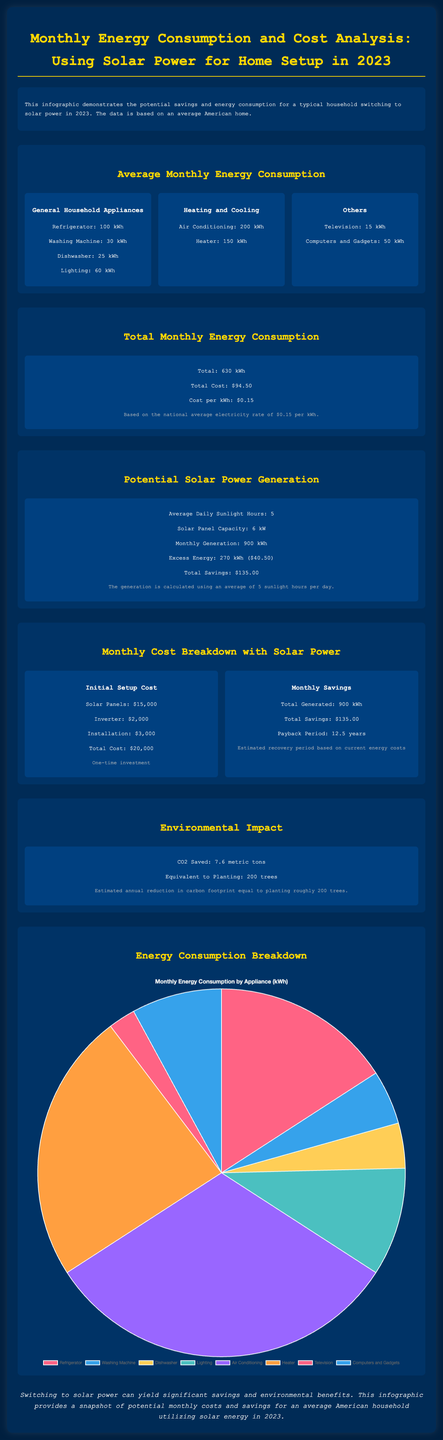What is the total monthly energy consumption? The total monthly energy consumption is listed in the section titled Total Monthly Energy Consumption as 630 kWh.
Answer: 630 kWh What is the cost per kWh? The cost per kWh is outlined in the Total Monthly Energy Consumption section as $0.15.
Answer: $0.15 How much CO2 is saved annually? The environmental impact section specifies that 7.6 metric tons of CO2 are saved annually.
Answer: 7.6 metric tons What is the total cost for solar panel installation? The initial setup cost section indicates the total cost for solar panel installation as $20,000.
Answer: $20,000 How much energy is generated monthly by solar panels? The potential solar power generation section states that the monthly generation is 900 kWh.
Answer: 900 kWh What is the payback period for the solar installation? The monthly savings section mentions that the payback period is estimated to be 12.5 years.
Answer: 12.5 years How many trees are equivalent to the CO2 savings? The environmental impact section notes that saving 7.6 metric tons of CO2 is equivalent to planting 200 trees.
Answer: 200 trees What is the total savings from using solar power? The potential solar power generation section indicates that total savings from using solar power is $135.00.
Answer: $135.00 